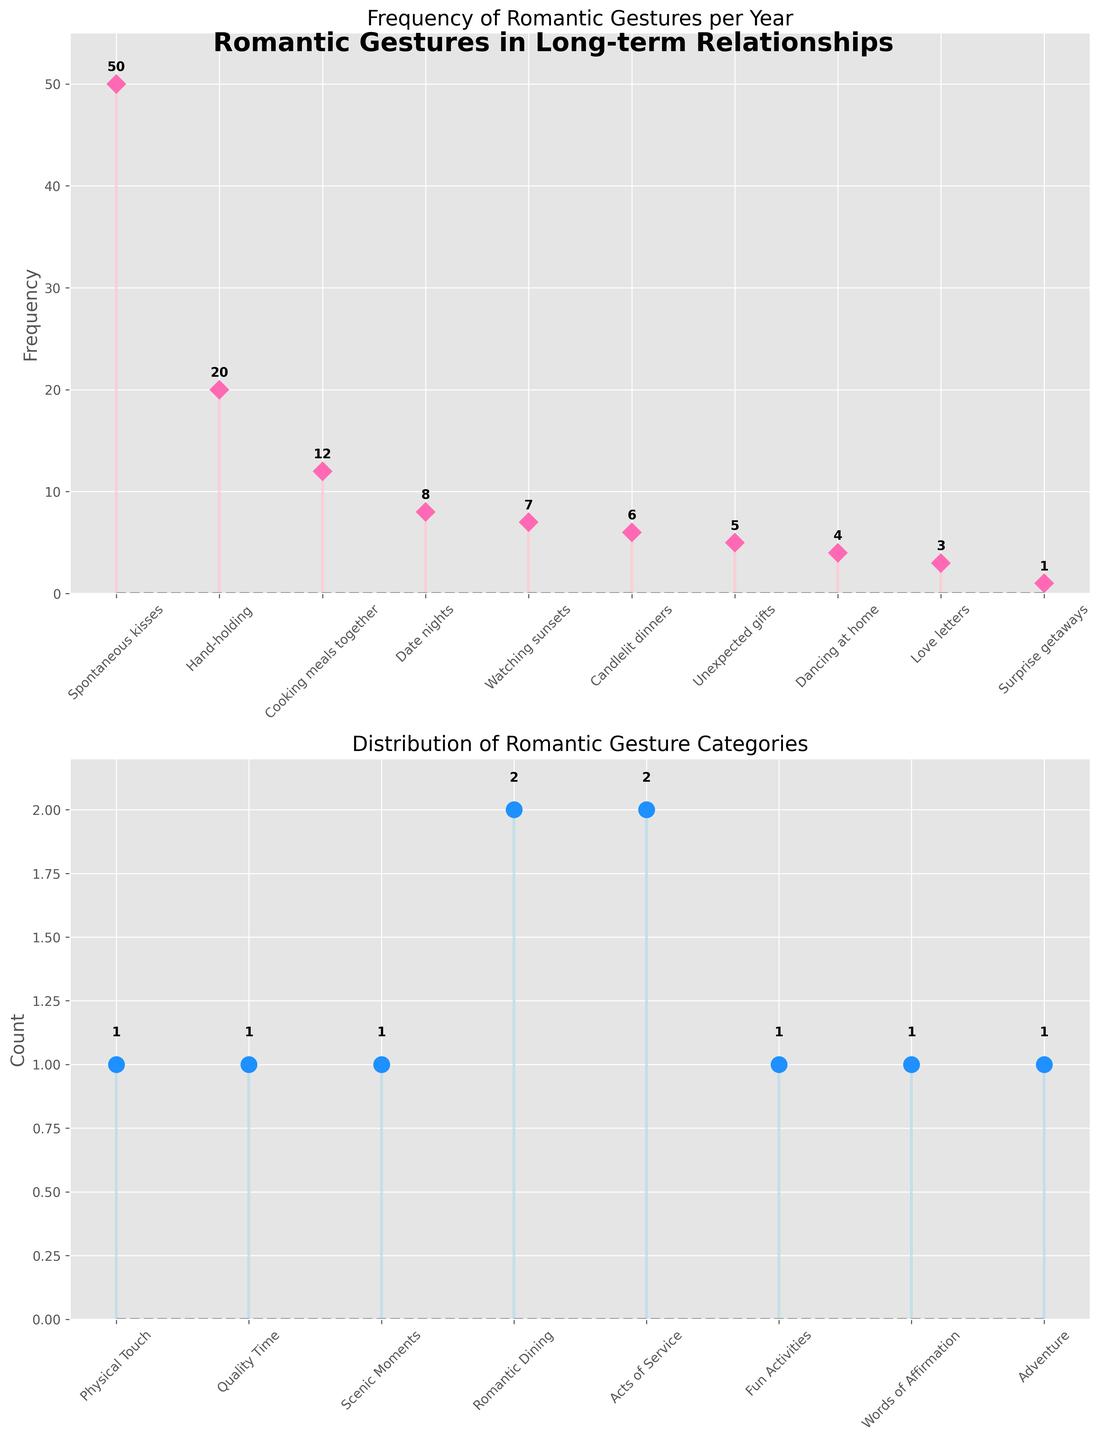What is the most frequent romantic gesture per year? The first subplot shows the frequency of each romantic gesture per year, and the tallest stem represents the most frequent gesture. From the stem plot, "Spontaneous kisses" have the highest value.
Answer: Spontaneous kisses How often do couples go on date nights per year? By looking at the plot of the frequency per year, the stem for "Date nights" is marked at 8.
Answer: 8 What is the total number of romantic gestures in the "Physical Touch" category? First, identify the gestures in the "Physical Touch" category from the data: "Hand-holding" and "Spontaneous kisses." Then, look at the subplot that categorizes the gestures. There are 2 gestures in this category.
Answer: 2 Which category has the highest number of romantic gestures? The second subplot shows the distribution of categories. The category with the tallest stem has the highest count, which is "Quality Time."
Answer: Quality Time What is the combined frequency of “Candlelit dinners” and “Watching sunsets” per year? Look at the frequencies of “Candlelit dinners” (6) and “Watching sunsets” (7) in the first subplot and sum them up: 6 + 7 = 13.
Answer: 13 How many more times per year do couples cook meals together compared to writing love letters? The frequency for "Cooking meals together" is 12, and for "Love letters," it is 3. Subtract the smaller frequency from the larger: 12 - 3 = 9.
Answer: 9 What categories do the least frequent romantic gestures fall under, and what are they? The least frequent romantic gesture, with a frequency of 1, is "Surprise getaways." According to the data, this gesture falls under the "Adventure" category.
Answer: Surprise getaways, Adventure What is the range of the frequencies of the gestures in the "Quality Time" category? The "Quality Time" category includes "Date nights" (8) and "Cooking meals together" (12). The range is calculated as the difference between the maximum and minimum values: 12 - 8 = 4.
Answer: 4 What is the second least frequent romantic gesture per year? Observe the first subplot to find the next smallest frequency above the least frequent. "Love letters" have a frequency of 3, making it the second least frequent gesture.
Answer: Love letters 